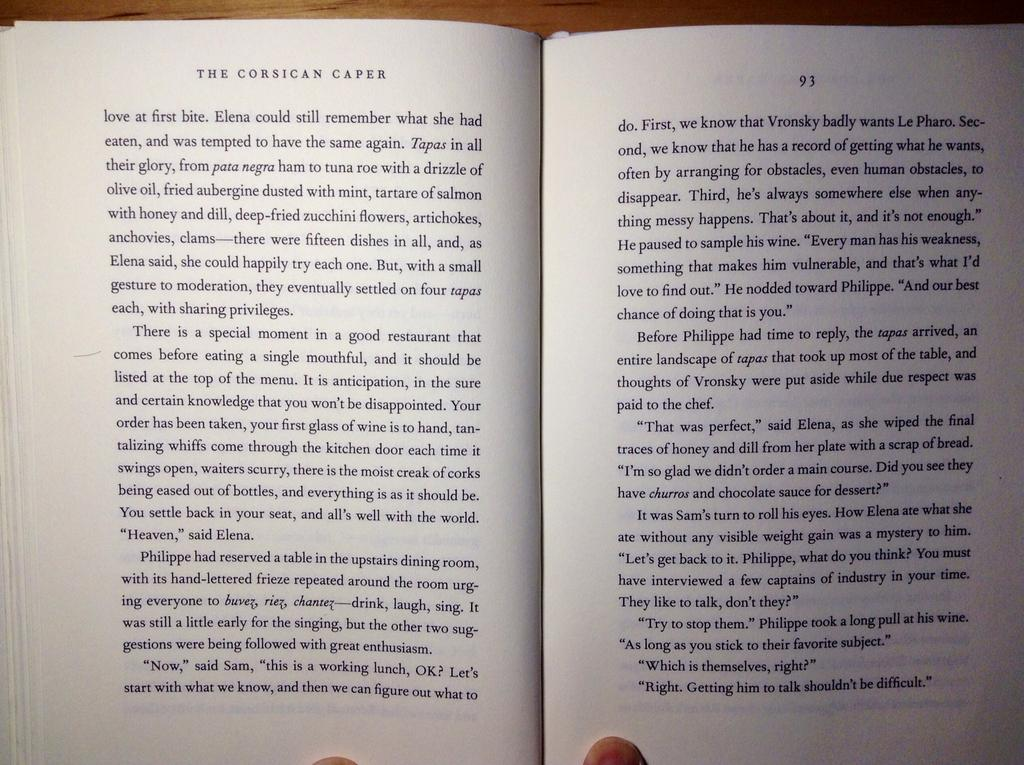<image>
Offer a succinct explanation of the picture presented. A book is opened to page 93, and the first paragraph on that page begins with the words Before Philippe had time to reply. 